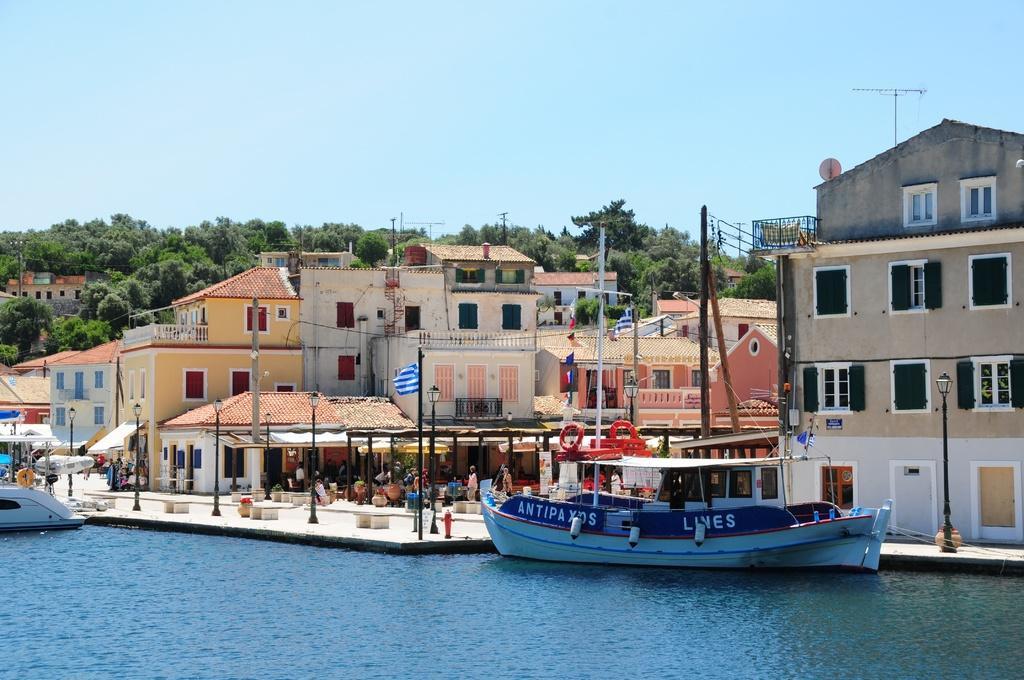In one or two sentences, can you explain what this image depicts? In this image there are two boats on the river, on the other side of the river there are trees and buildings, in front of the building there are lamp posts, flag posts and there are a few people walking on the streets. 